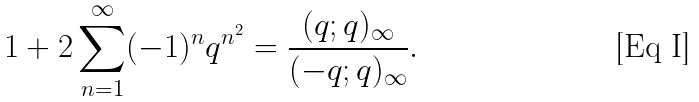<formula> <loc_0><loc_0><loc_500><loc_500>1 + 2 \sum _ { n = 1 } ^ { \infty } ( - 1 ) ^ { n } q ^ { n ^ { 2 } } = \frac { ( q ; q ) _ { \infty } } { ( - q ; q ) _ { \infty } } .</formula> 